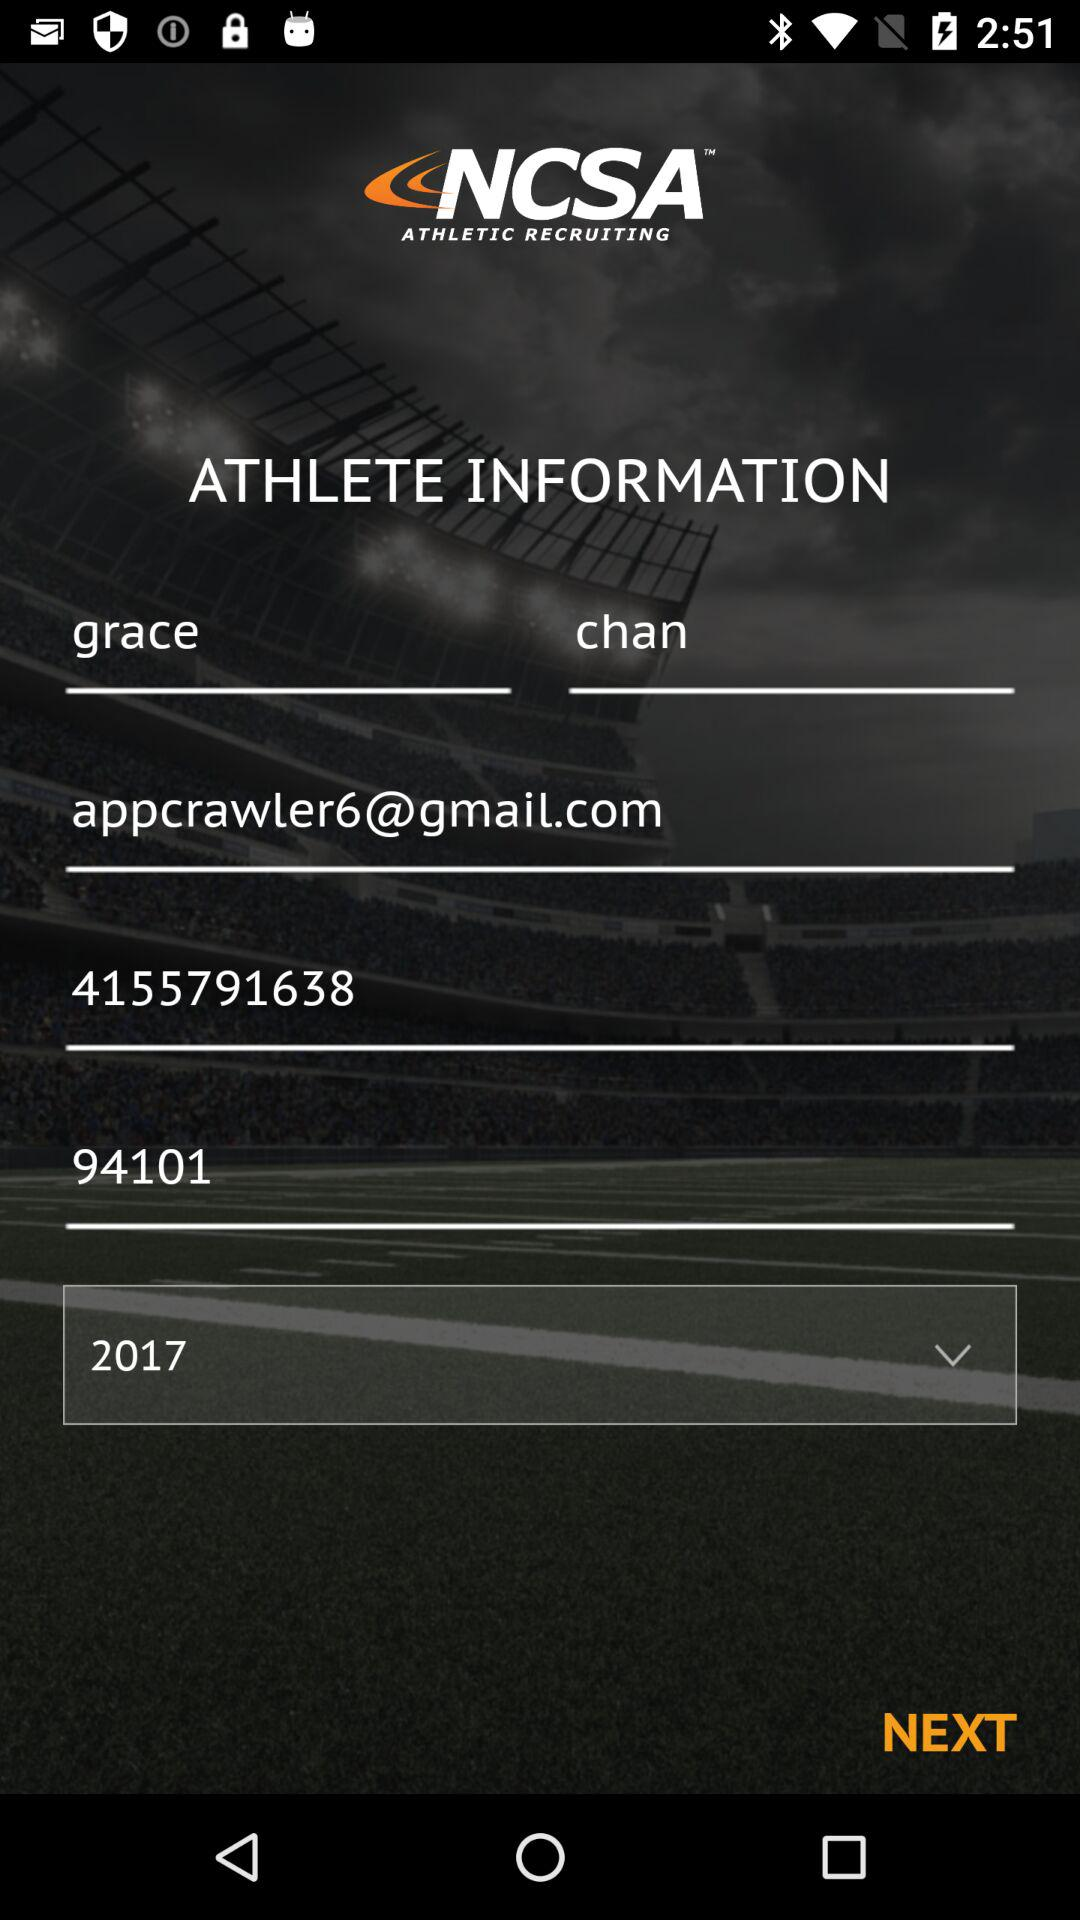Which year is selected for athlete information? The year selected for athlete information is 2017. 